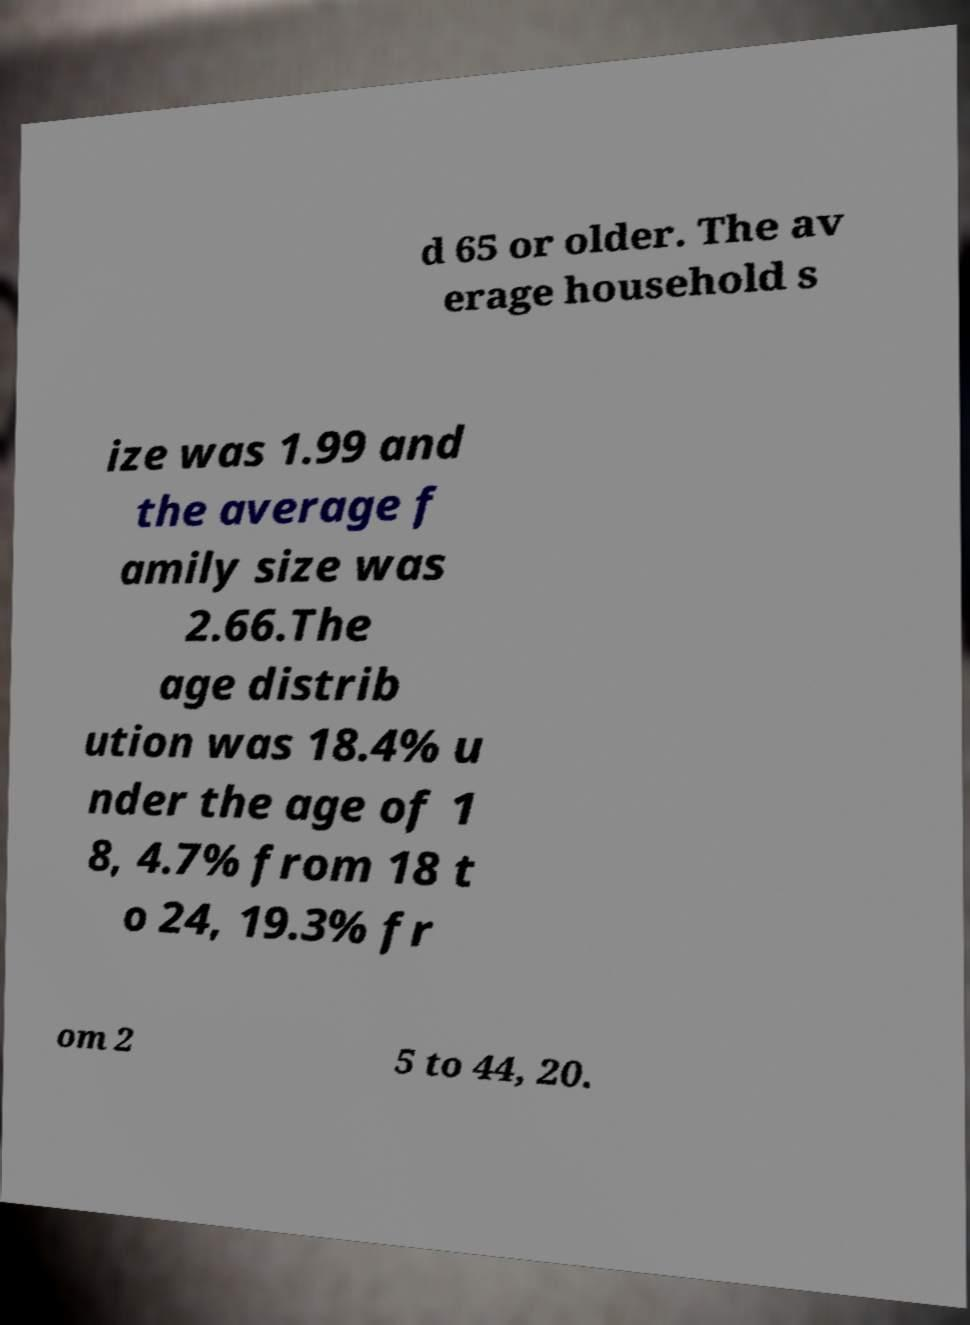What messages or text are displayed in this image? I need them in a readable, typed format. d 65 or older. The av erage household s ize was 1.99 and the average f amily size was 2.66.The age distrib ution was 18.4% u nder the age of 1 8, 4.7% from 18 t o 24, 19.3% fr om 2 5 to 44, 20. 